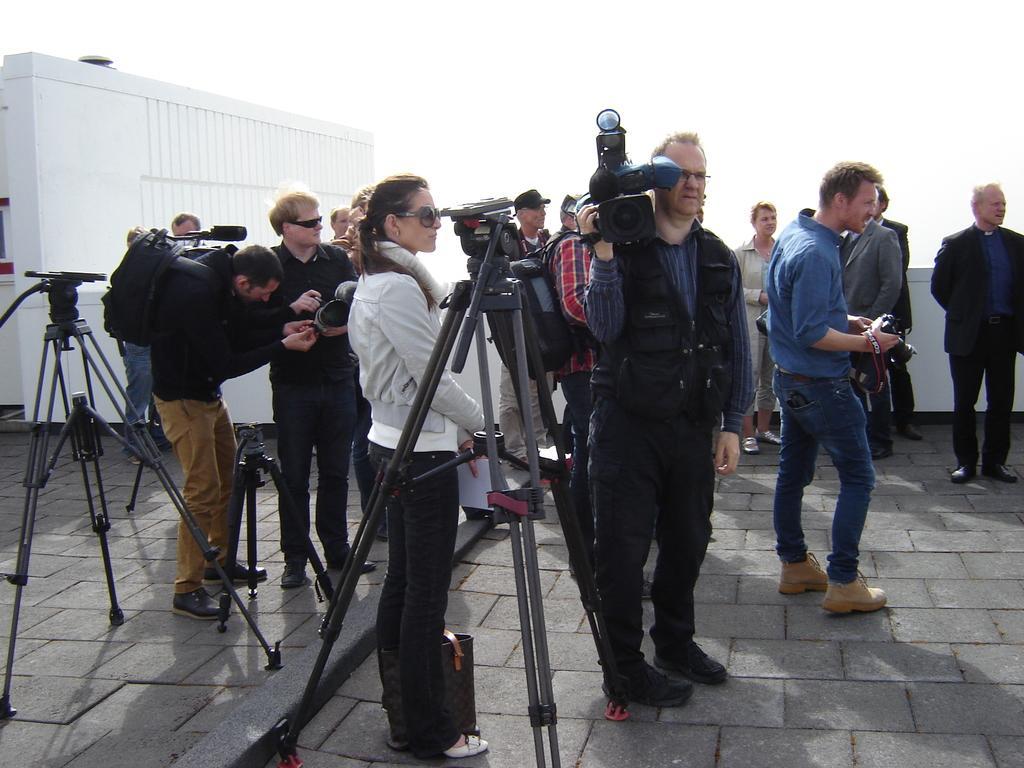Can you describe this image briefly? In this picture I can see group of people are standing on the ground among them few are holding cameras. I can also see camera stand and other objects on the ground. In the background I can see sky and white color wall. 